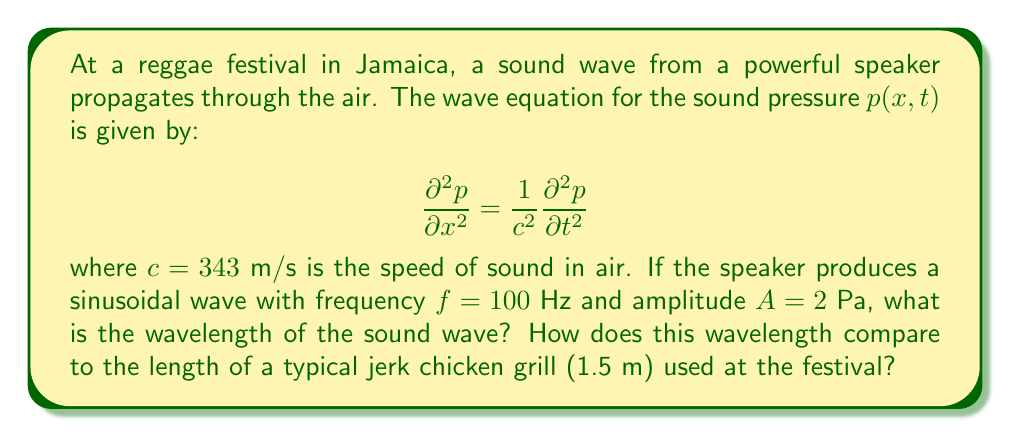What is the answer to this math problem? To solve this problem, we'll follow these steps:

1) First, recall the relation between wavelength ($\lambda$), frequency ($f$), and wave speed ($c$):

   $$c = f\lambda$$

2) We're given the frequency $f = 100$ Hz and the speed of sound $c = 343$ m/s. Let's rearrange the equation to solve for $\lambda$:

   $$\lambda = \frac{c}{f}$$

3) Now, let's substitute the values:

   $$\lambda = \frac{343 \text{ m/s}}{100 \text{ Hz}} = 3.43 \text{ m}$$

4) To compare this to the length of a typical jerk chicken grill (1.5 m):

   $$\frac{\text{Wavelength}}{\text{Grill length}} = \frac{3.43 \text{ m}}{1.5 \text{ m}} \approx 2.29$$

5) This means the wavelength is about 2.29 times longer than the grill.

Note: The amplitude $A$ given in the problem isn't needed for this calculation, but it would be relevant if we were asked about the intensity of the sound.
Answer: $\lambda = 3.43$ m; 2.29 times longer than the grill 